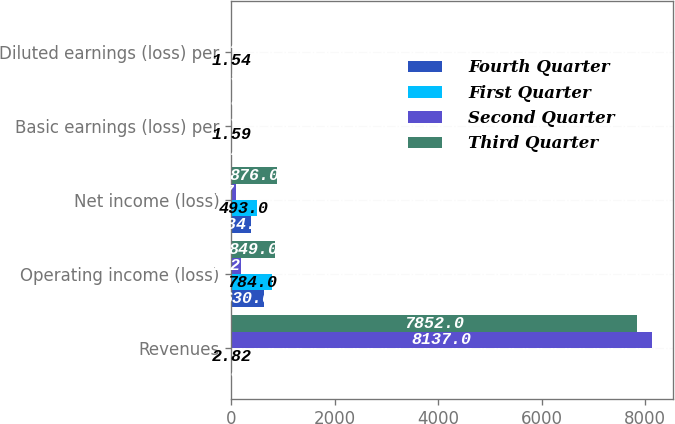Convert chart to OTSL. <chart><loc_0><loc_0><loc_500><loc_500><stacked_bar_chart><ecel><fcel>Revenues<fcel>Operating income (loss)<fcel>Net income (loss)<fcel>Basic earnings (loss) per<fcel>Diluted earnings (loss) per<nl><fcel>Fourth Quarter<fcel>2.82<fcel>630<fcel>384<fcel>1.23<fcel>1.58<nl><fcel>First Quarter<fcel>2.82<fcel>784<fcel>493<fcel>1.59<fcel>1.54<nl><fcel>Second Quarter<fcel>8137<fcel>182<fcel>97<fcel>0.31<fcel>1.26<nl><fcel>Third Quarter<fcel>7852<fcel>849<fcel>876<fcel>2.82<fcel>0.78<nl></chart> 